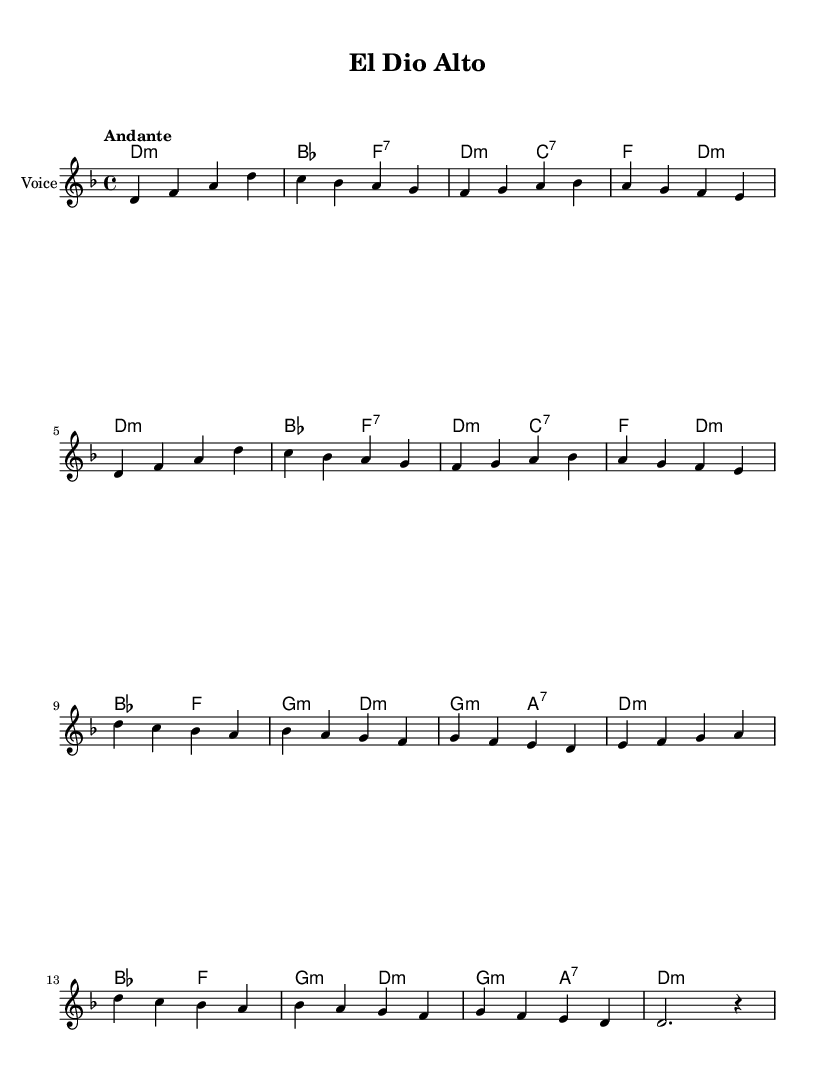What is the key signature of this music? The key signature includes two flats, which indicate the notes B flat and E flat; therefore, the key signature is D minor.
Answer: D minor What is the time signature of this piece? The time signature appears as 4/4 in the music, which means there are four beats per measure, and the quarter note gets one beat.
Answer: 4/4 What tempo marking is indicated in the score? The tempo is marked as "Andante," which implies a moderately slow pace in the performance of the piece.
Answer: Andante How many measures are present in the melody? By counting each group of bars in the melody, we can see there are 16 measures in total.
Answer: 16 What is the harmonic structure of the piece? The harmonic structure is based on a sequence of chords, starting with D minor, moving through various seventh chords like B flat and ending with D minor.
Answer: D minor, B flat, D What is the repeating pattern in the melody? The first eight measures repeat the same melodic pattern before moving into new material in the second half.
Answer: Repetition in first eight measures What type of liturgical song does this represent? This piece is categorized as a Sephardic Jewish liturgical song, often reflecting the cultural and religious themes important in the community.
Answer: Sephardic 